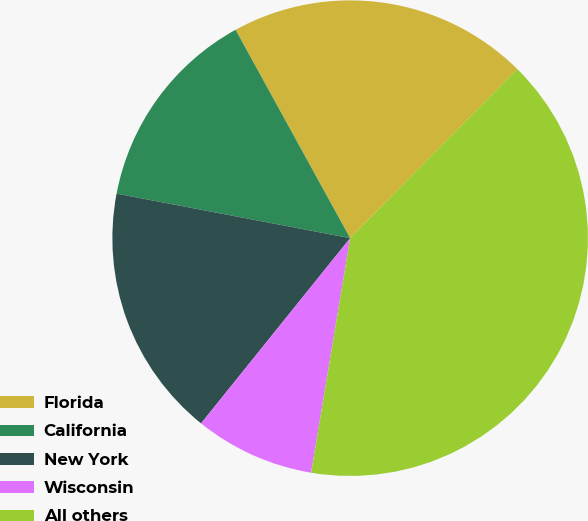Convert chart to OTSL. <chart><loc_0><loc_0><loc_500><loc_500><pie_chart><fcel>Florida<fcel>California<fcel>New York<fcel>Wisconsin<fcel>All others<nl><fcel>20.41%<fcel>14.0%<fcel>17.21%<fcel>8.16%<fcel>40.21%<nl></chart> 